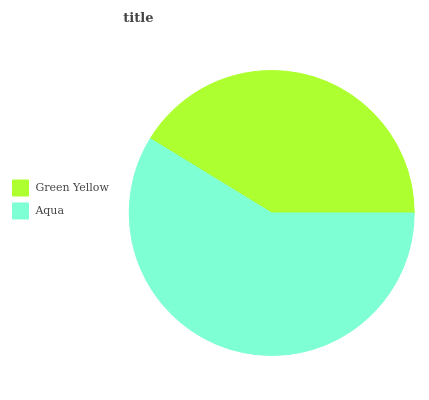Is Green Yellow the minimum?
Answer yes or no. Yes. Is Aqua the maximum?
Answer yes or no. Yes. Is Aqua the minimum?
Answer yes or no. No. Is Aqua greater than Green Yellow?
Answer yes or no. Yes. Is Green Yellow less than Aqua?
Answer yes or no. Yes. Is Green Yellow greater than Aqua?
Answer yes or no. No. Is Aqua less than Green Yellow?
Answer yes or no. No. Is Aqua the high median?
Answer yes or no. Yes. Is Green Yellow the low median?
Answer yes or no. Yes. Is Green Yellow the high median?
Answer yes or no. No. Is Aqua the low median?
Answer yes or no. No. 